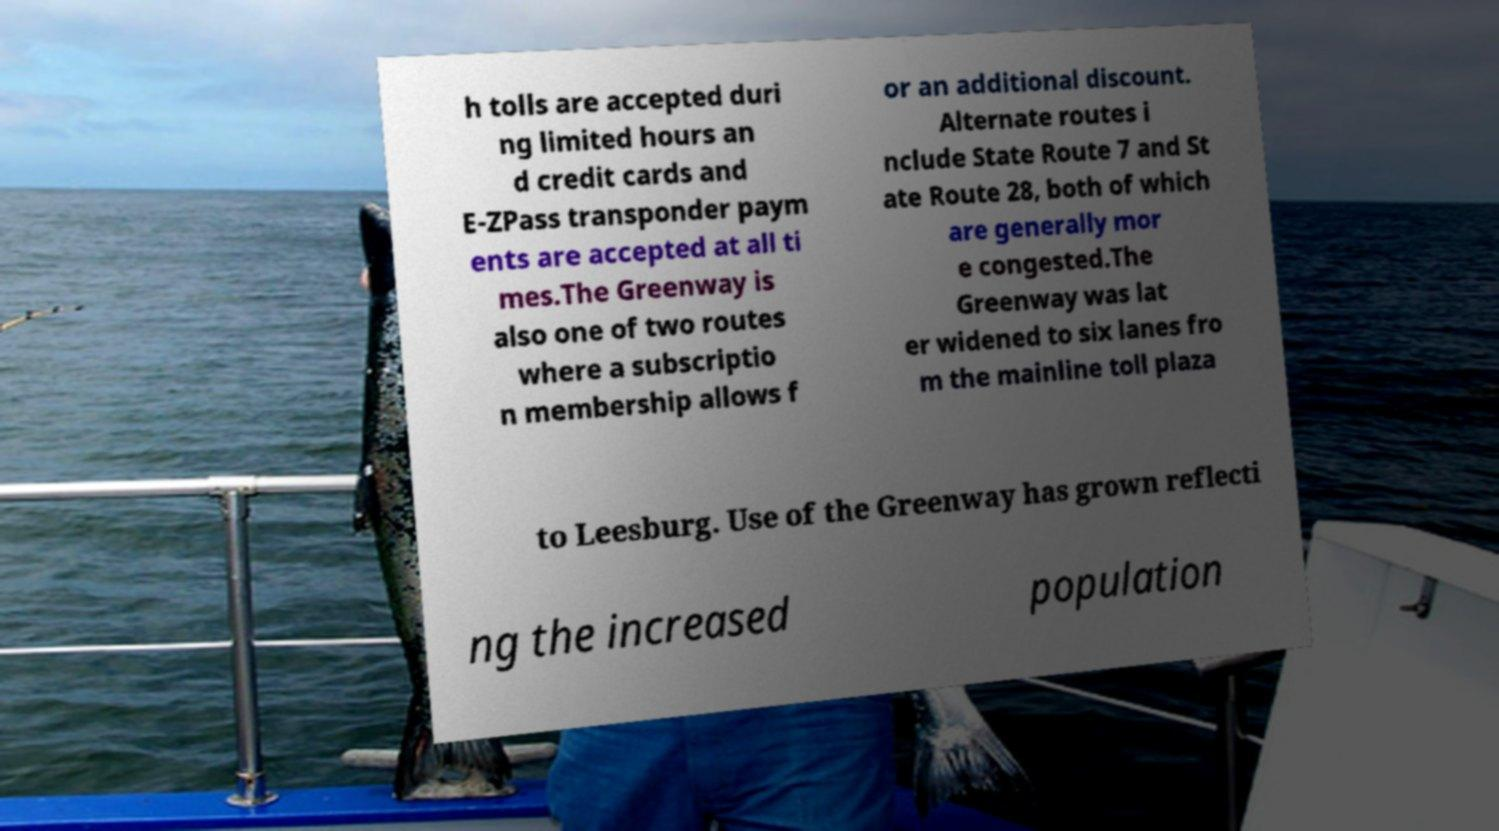There's text embedded in this image that I need extracted. Can you transcribe it verbatim? h tolls are accepted duri ng limited hours an d credit cards and E-ZPass transponder paym ents are accepted at all ti mes.The Greenway is also one of two routes where a subscriptio n membership allows f or an additional discount. Alternate routes i nclude State Route 7 and St ate Route 28, both of which are generally mor e congested.The Greenway was lat er widened to six lanes fro m the mainline toll plaza to Leesburg. Use of the Greenway has grown reflecti ng the increased population 